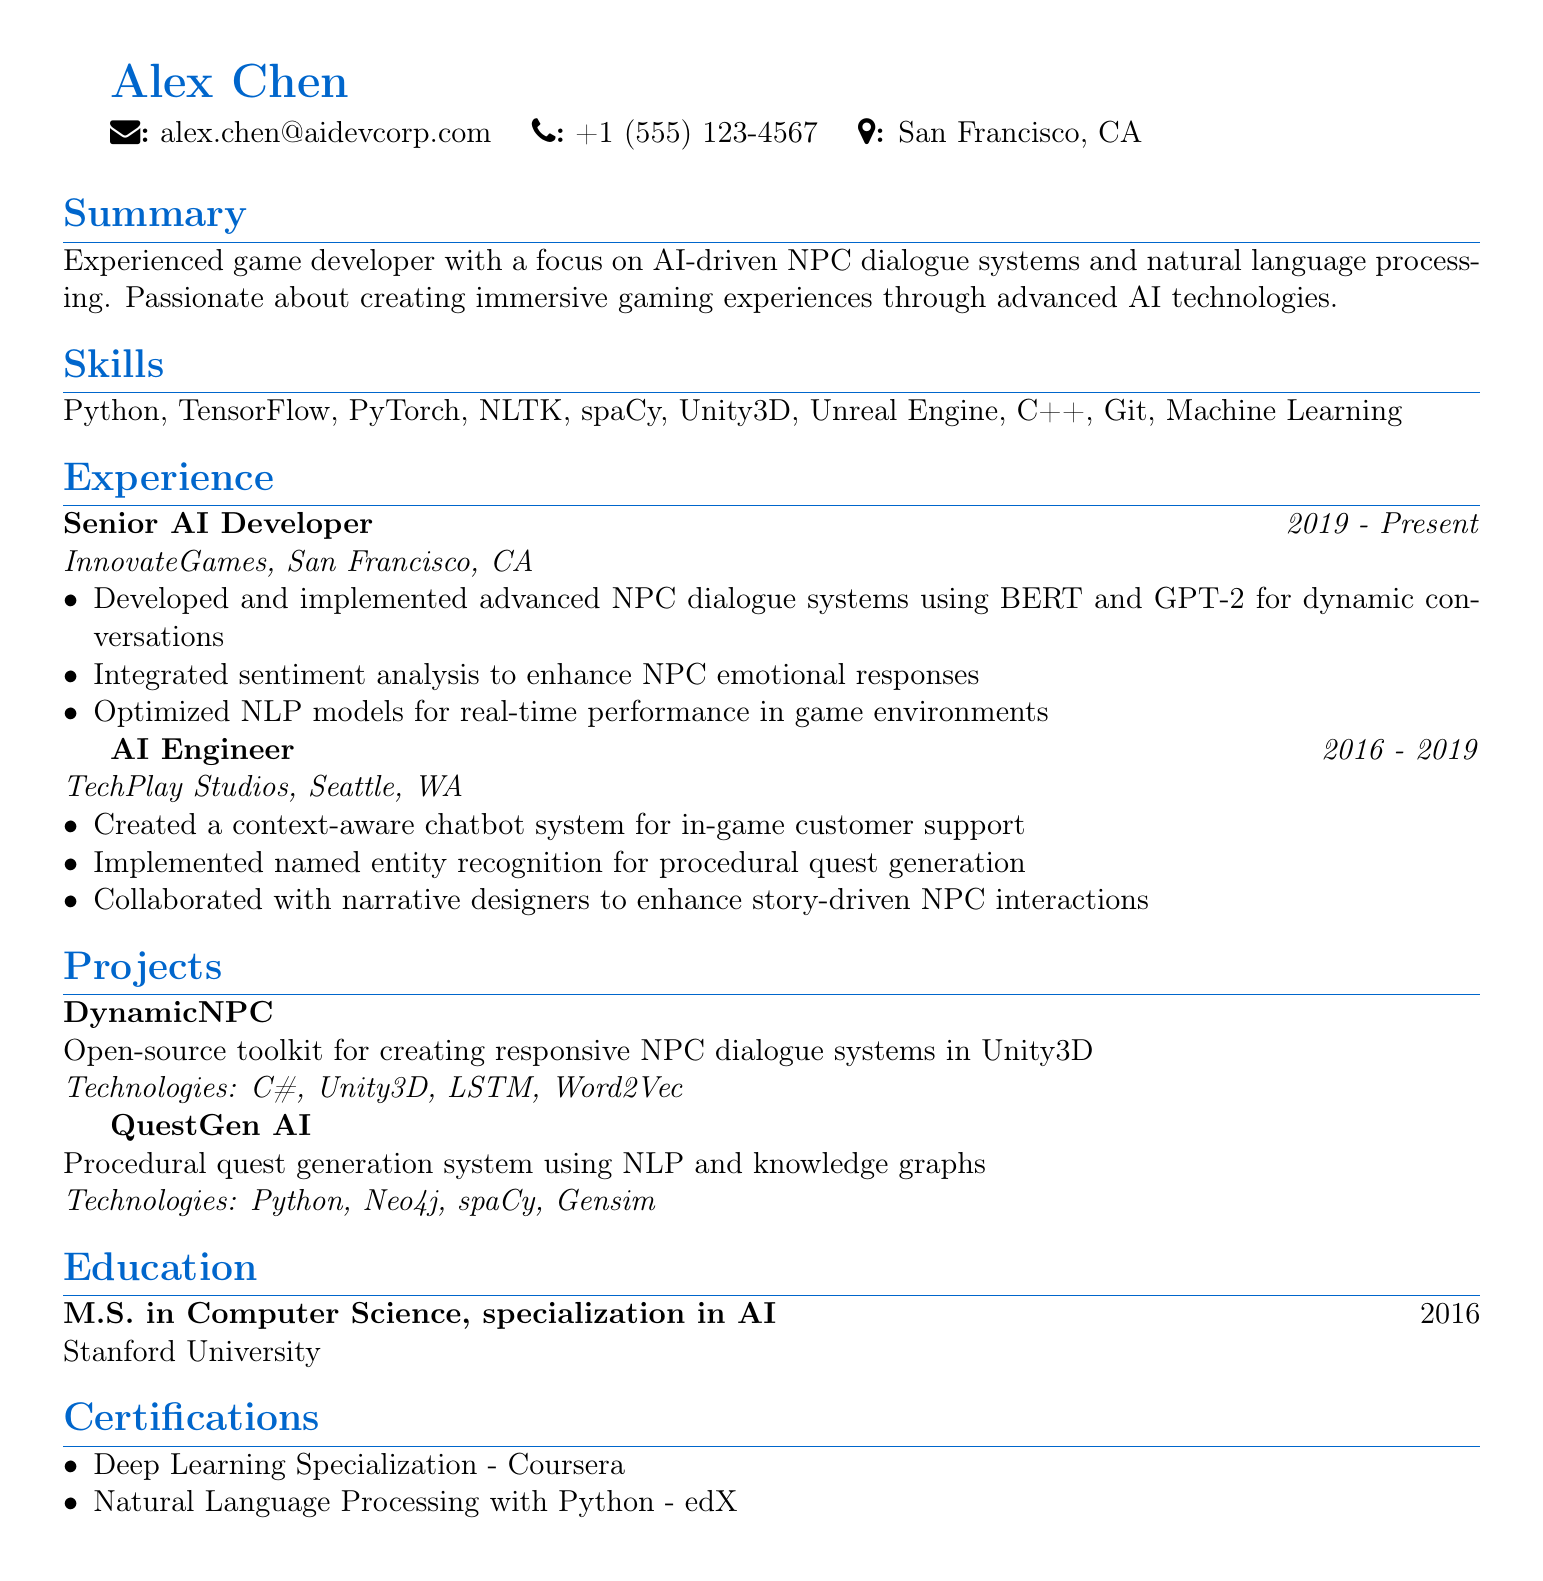what is the name of the candidate? The document lists the candidate's name as Alex Chen.
Answer: Alex Chen what is the candidate's email address? The document provides the email address as alex.chen@aidevcorp.com.
Answer: alex.chen@aidevcorp.com what is the highest degree achieved by the candidate? The education section states the degree achieved is M.S. in Computer Science.
Answer: M.S. in Computer Science how many years of experience does the candidate have in AI development? The candidate's experience spans from 2016 to the present, giving them approximately 7 years.
Answer: 7 years which technology was used in the project named "QuestGen AI"? The project description mentions the use of Python among other technologies.
Answer: Python what role did the candidate hold at InnovateGames? The position is specified as Senior AI Developer.
Answer: Senior AI Developer which toolkit is available as open-source for NPC dialogue systems? The resume mentions the toolkit "DynamicNPC" as open-source.
Answer: DynamicNPC what technology does the candidate use for sentiment analysis in NPCs? The responsibilities section indicates sentiment analysis is enhanced using advanced NLP models.
Answer: NLP models how many certifications does the candidate hold? There are two certifications listed in the document.
Answer: 2 